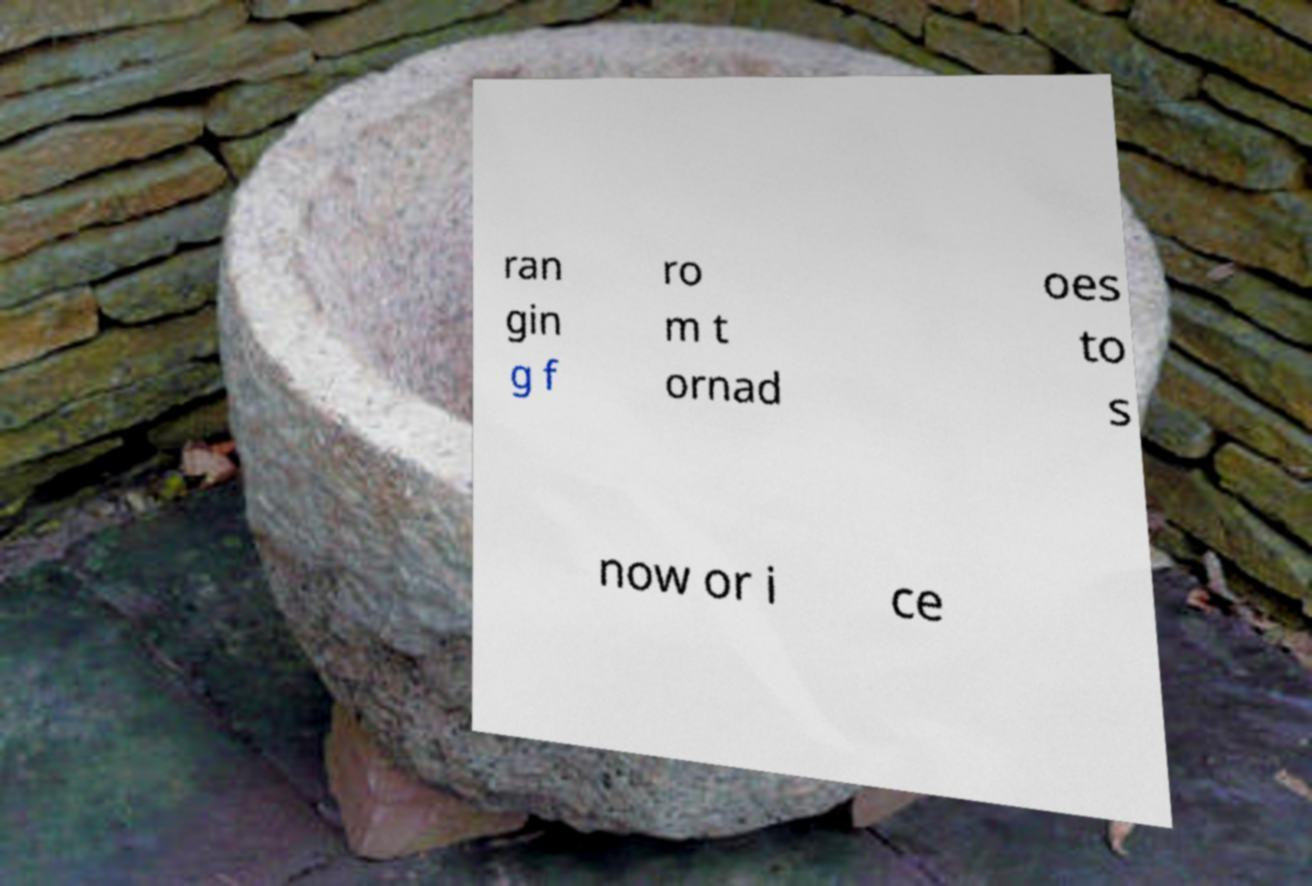I need the written content from this picture converted into text. Can you do that? ran gin g f ro m t ornad oes to s now or i ce 